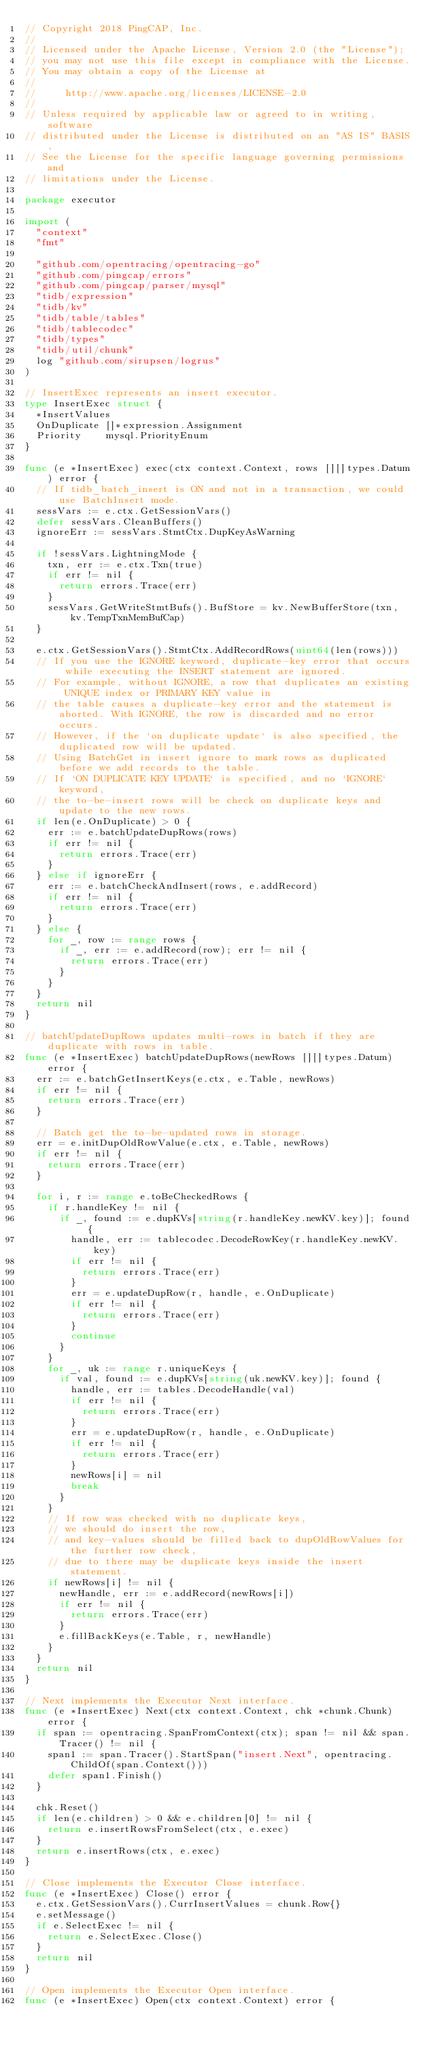<code> <loc_0><loc_0><loc_500><loc_500><_Go_>// Copyright 2018 PingCAP, Inc.
//
// Licensed under the Apache License, Version 2.0 (the "License");
// you may not use this file except in compliance with the License.
// You may obtain a copy of the License at
//
//     http://www.apache.org/licenses/LICENSE-2.0
//
// Unless required by applicable law or agreed to in writing, software
// distributed under the License is distributed on an "AS IS" BASIS,
// See the License for the specific language governing permissions and
// limitations under the License.

package executor

import (
	"context"
	"fmt"

	"github.com/opentracing/opentracing-go"
	"github.com/pingcap/errors"
	"github.com/pingcap/parser/mysql"
	"tidb/expression"
	"tidb/kv"
	"tidb/table/tables"
	"tidb/tablecodec"
	"tidb/types"
	"tidb/util/chunk"
	log "github.com/sirupsen/logrus"
)

// InsertExec represents an insert executor.
type InsertExec struct {
	*InsertValues
	OnDuplicate []*expression.Assignment
	Priority    mysql.PriorityEnum
}

func (e *InsertExec) exec(ctx context.Context, rows [][]types.Datum) error {
	// If tidb_batch_insert is ON and not in a transaction, we could use BatchInsert mode.
	sessVars := e.ctx.GetSessionVars()
	defer sessVars.CleanBuffers()
	ignoreErr := sessVars.StmtCtx.DupKeyAsWarning

	if !sessVars.LightningMode {
		txn, err := e.ctx.Txn(true)
		if err != nil {
			return errors.Trace(err)
		}
		sessVars.GetWriteStmtBufs().BufStore = kv.NewBufferStore(txn, kv.TempTxnMemBufCap)
	}

	e.ctx.GetSessionVars().StmtCtx.AddRecordRows(uint64(len(rows)))
	// If you use the IGNORE keyword, duplicate-key error that occurs while executing the INSERT statement are ignored.
	// For example, without IGNORE, a row that duplicates an existing UNIQUE index or PRIMARY KEY value in
	// the table causes a duplicate-key error and the statement is aborted. With IGNORE, the row is discarded and no error occurs.
	// However, if the `on duplicate update` is also specified, the duplicated row will be updated.
	// Using BatchGet in insert ignore to mark rows as duplicated before we add records to the table.
	// If `ON DUPLICATE KEY UPDATE` is specified, and no `IGNORE` keyword,
	// the to-be-insert rows will be check on duplicate keys and update to the new rows.
	if len(e.OnDuplicate) > 0 {
		err := e.batchUpdateDupRows(rows)
		if err != nil {
			return errors.Trace(err)
		}
	} else if ignoreErr {
		err := e.batchCheckAndInsert(rows, e.addRecord)
		if err != nil {
			return errors.Trace(err)
		}
	} else {
		for _, row := range rows {
			if _, err := e.addRecord(row); err != nil {
				return errors.Trace(err)
			}
		}
	}
	return nil
}

// batchUpdateDupRows updates multi-rows in batch if they are duplicate with rows in table.
func (e *InsertExec) batchUpdateDupRows(newRows [][]types.Datum) error {
	err := e.batchGetInsertKeys(e.ctx, e.Table, newRows)
	if err != nil {
		return errors.Trace(err)
	}

	// Batch get the to-be-updated rows in storage.
	err = e.initDupOldRowValue(e.ctx, e.Table, newRows)
	if err != nil {
		return errors.Trace(err)
	}

	for i, r := range e.toBeCheckedRows {
		if r.handleKey != nil {
			if _, found := e.dupKVs[string(r.handleKey.newKV.key)]; found {
				handle, err := tablecodec.DecodeRowKey(r.handleKey.newKV.key)
				if err != nil {
					return errors.Trace(err)
				}
				err = e.updateDupRow(r, handle, e.OnDuplicate)
				if err != nil {
					return errors.Trace(err)
				}
				continue
			}
		}
		for _, uk := range r.uniqueKeys {
			if val, found := e.dupKVs[string(uk.newKV.key)]; found {
				handle, err := tables.DecodeHandle(val)
				if err != nil {
					return errors.Trace(err)
				}
				err = e.updateDupRow(r, handle, e.OnDuplicate)
				if err != nil {
					return errors.Trace(err)
				}
				newRows[i] = nil
				break
			}
		}
		// If row was checked with no duplicate keys,
		// we should do insert the row,
		// and key-values should be filled back to dupOldRowValues for the further row check,
		// due to there may be duplicate keys inside the insert statement.
		if newRows[i] != nil {
			newHandle, err := e.addRecord(newRows[i])
			if err != nil {
				return errors.Trace(err)
			}
			e.fillBackKeys(e.Table, r, newHandle)
		}
	}
	return nil
}

// Next implements the Executor Next interface.
func (e *InsertExec) Next(ctx context.Context, chk *chunk.Chunk) error {
	if span := opentracing.SpanFromContext(ctx); span != nil && span.Tracer() != nil {
		span1 := span.Tracer().StartSpan("insert.Next", opentracing.ChildOf(span.Context()))
		defer span1.Finish()
	}

	chk.Reset()
	if len(e.children) > 0 && e.children[0] != nil {
		return e.insertRowsFromSelect(ctx, e.exec)
	}
	return e.insertRows(ctx, e.exec)
}

// Close implements the Executor Close interface.
func (e *InsertExec) Close() error {
	e.ctx.GetSessionVars().CurrInsertValues = chunk.Row{}
	e.setMessage()
	if e.SelectExec != nil {
		return e.SelectExec.Close()
	}
	return nil
}

// Open implements the Executor Open interface.
func (e *InsertExec) Open(ctx context.Context) error {</code> 